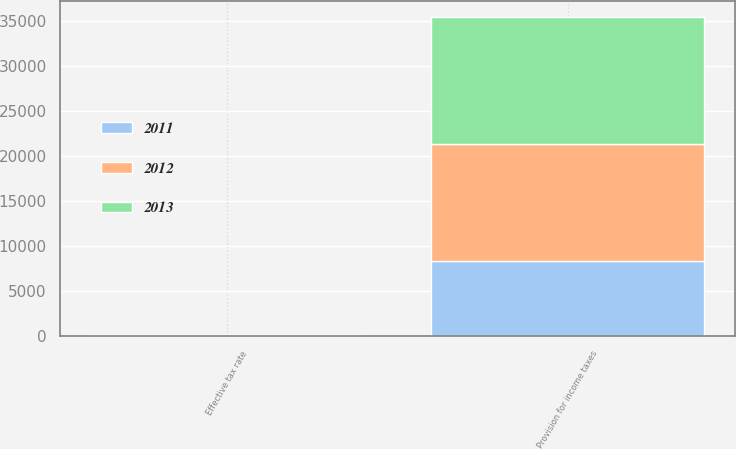Convert chart. <chart><loc_0><loc_0><loc_500><loc_500><stacked_bar_chart><ecel><fcel>Provision for income taxes<fcel>Effective tax rate<nl><fcel>2012<fcel>13118<fcel>26.2<nl><fcel>2013<fcel>14030<fcel>25.2<nl><fcel>2011<fcel>8283<fcel>24.2<nl></chart> 